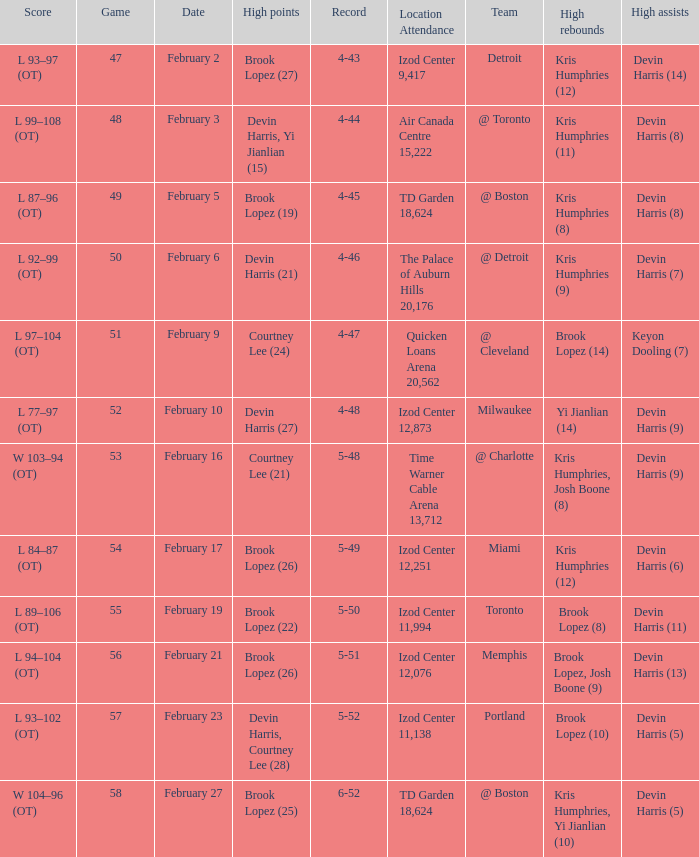Could you parse the entire table? {'header': ['Score', 'Game', 'Date', 'High points', 'Record', 'Location Attendance', 'Team', 'High rebounds', 'High assists'], 'rows': [['L 93–97 (OT)', '47', 'February 2', 'Brook Lopez (27)', '4-43', 'Izod Center 9,417', 'Detroit', 'Kris Humphries (12)', 'Devin Harris (14)'], ['L 99–108 (OT)', '48', 'February 3', 'Devin Harris, Yi Jianlian (15)', '4-44', 'Air Canada Centre 15,222', '@ Toronto', 'Kris Humphries (11)', 'Devin Harris (8)'], ['L 87–96 (OT)', '49', 'February 5', 'Brook Lopez (19)', '4-45', 'TD Garden 18,624', '@ Boston', 'Kris Humphries (8)', 'Devin Harris (8)'], ['L 92–99 (OT)', '50', 'February 6', 'Devin Harris (21)', '4-46', 'The Palace of Auburn Hills 20,176', '@ Detroit', 'Kris Humphries (9)', 'Devin Harris (7)'], ['L 97–104 (OT)', '51', 'February 9', 'Courtney Lee (24)', '4-47', 'Quicken Loans Arena 20,562', '@ Cleveland', 'Brook Lopez (14)', 'Keyon Dooling (7)'], ['L 77–97 (OT)', '52', 'February 10', 'Devin Harris (27)', '4-48', 'Izod Center 12,873', 'Milwaukee', 'Yi Jianlian (14)', 'Devin Harris (9)'], ['W 103–94 (OT)', '53', 'February 16', 'Courtney Lee (21)', '5-48', 'Time Warner Cable Arena 13,712', '@ Charlotte', 'Kris Humphries, Josh Boone (8)', 'Devin Harris (9)'], ['L 84–87 (OT)', '54', 'February 17', 'Brook Lopez (26)', '5-49', 'Izod Center 12,251', 'Miami', 'Kris Humphries (12)', 'Devin Harris (6)'], ['L 89–106 (OT)', '55', 'February 19', 'Brook Lopez (22)', '5-50', 'Izod Center 11,994', 'Toronto', 'Brook Lopez (8)', 'Devin Harris (11)'], ['L 94–104 (OT)', '56', 'February 21', 'Brook Lopez (26)', '5-51', 'Izod Center 12,076', 'Memphis', 'Brook Lopez, Josh Boone (9)', 'Devin Harris (13)'], ['L 93–102 (OT)', '57', 'February 23', 'Devin Harris, Courtney Lee (28)', '5-52', 'Izod Center 11,138', 'Portland', 'Brook Lopez (10)', 'Devin Harris (5)'], ['W 104–96 (OT)', '58', 'February 27', 'Brook Lopez (25)', '6-52', 'TD Garden 18,624', '@ Boston', 'Kris Humphries, Yi Jianlian (10)', 'Devin Harris (5)']]} What's the highest game number for a game in which Kris Humphries (8) did the high rebounds? 49.0. 